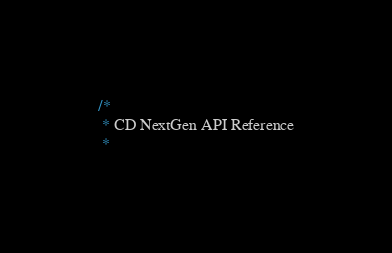Convert code to text. <code><loc_0><loc_0><loc_500><loc_500><_Go_>/*
 * CD NextGen API Reference
 *</code> 